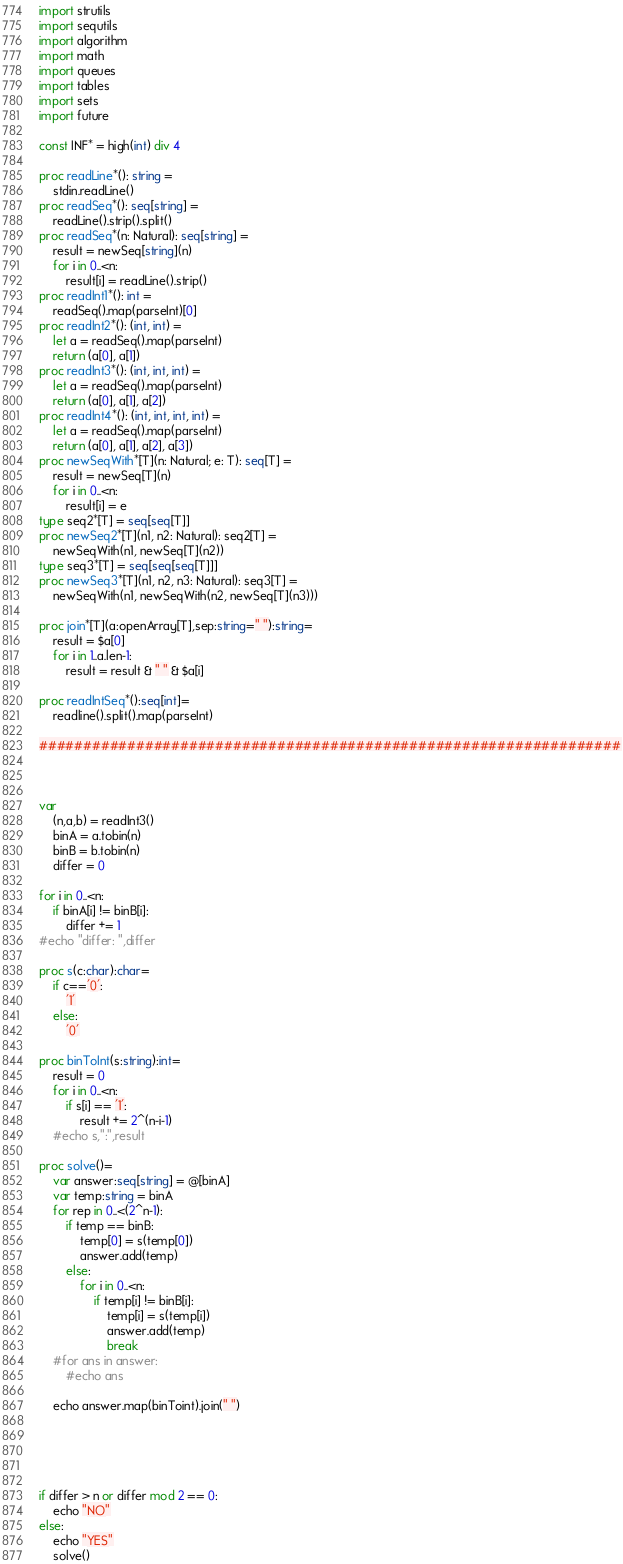<code> <loc_0><loc_0><loc_500><loc_500><_Nim_>import strutils
import sequtils
import algorithm
import math
import queues
import tables
import sets
import future
 
const INF* = high(int) div 4
 
proc readLine*(): string =
    stdin.readLine()
proc readSeq*(): seq[string] =
    readLine().strip().split()
proc readSeq*(n: Natural): seq[string] =
    result = newSeq[string](n)
    for i in 0..<n:
        result[i] = readLine().strip()
proc readInt1*(): int =
    readSeq().map(parseInt)[0]
proc readInt2*(): (int, int) =
    let a = readSeq().map(parseInt)
    return (a[0], a[1])
proc readInt3*(): (int, int, int) =
    let a = readSeq().map(parseInt)
    return (a[0], a[1], a[2])
proc readInt4*(): (int, int, int, int) =
    let a = readSeq().map(parseInt)
    return (a[0], a[1], a[2], a[3])
proc newSeqWith*[T](n: Natural; e: T): seq[T] =
    result = newSeq[T](n)
    for i in 0..<n:
        result[i] = e
type seq2*[T] = seq[seq[T]]
proc newSeq2*[T](n1, n2: Natural): seq2[T] =
    newSeqWith(n1, newSeq[T](n2))
type seq3*[T] = seq[seq[seq[T]]]
proc newSeq3*[T](n1, n2, n3: Natural): seq3[T] =
    newSeqWith(n1, newSeqWith(n2, newSeq[T](n3)))

proc join*[T](a:openArray[T],sep:string=" "):string=
    result = $a[0]
    for i in 1..a.len-1:
        result = result & " " & $a[i]

proc readIntSeq*():seq[int]=
    readline().split().map(parseInt)

##################################################################



var
    (n,a,b) = readInt3()
    binA = a.tobin(n)
    binB = b.tobin(n)
    differ = 0

for i in 0..<n:
    if binA[i] != binB[i]:
        differ += 1
#echo "differ: ",differ

proc s(c:char):char=
    if c=='0':
        '1'
    else:
        '0'

proc binToInt(s:string):int=
    result = 0
    for i in 0..<n:
        if s[i] == '1':
            result += 2^(n-i-1)
    #echo s,":",result

proc solve()=
    var answer:seq[string] = @[binA]
    var temp:string = binA
    for rep in 0..<(2^n-1):
        if temp == binB:
            temp[0] = s(temp[0])
            answer.add(temp)
        else:
            for i in 0..<n:
                if temp[i] != binB[i]:
                    temp[i] = s(temp[i])
                    answer.add(temp)
                    break
    #for ans in answer:
        #echo ans

    echo answer.map(binToint).join(" ")
    
        
            


if differ > n or differ mod 2 == 0:
    echo "NO"
else:
    echo "YES"
    solve()</code> 